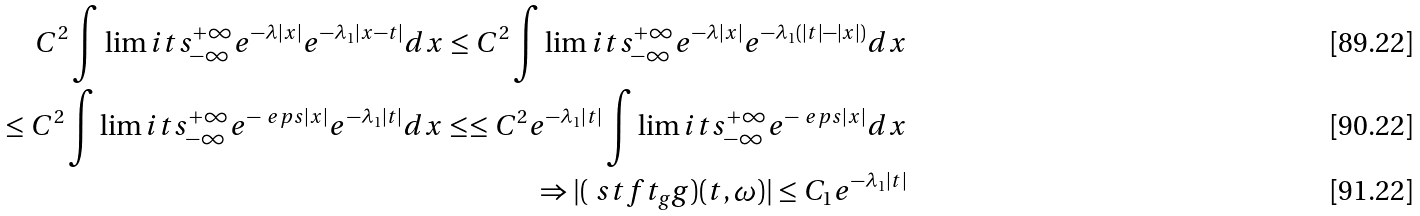<formula> <loc_0><loc_0><loc_500><loc_500>C ^ { 2 } \int \lim i t s _ { - \infty } ^ { + \infty } e ^ { - \lambda | x | } e ^ { - \lambda _ { 1 } | x - t | } d x \leq C ^ { 2 } \int \lim i t s _ { - \infty } ^ { + \infty } e ^ { - \lambda | x | } e ^ { - \lambda _ { 1 } ( | t | - | x | ) } d x \\ \leq C ^ { 2 } \int \lim i t s _ { - \infty } ^ { + \infty } e ^ { - \ e p s | x | } e ^ { - \lambda _ { 1 } | t | } d x \leq \leq C ^ { 2 } e ^ { - \lambda _ { 1 } | t | } \int \lim i t s _ { - \infty } ^ { + \infty } e ^ { - \ e p s | x | } d x \\ \Rightarrow | ( \ s t f t _ { g } g ) ( t , \omega ) | \leq C _ { 1 } e ^ { - \lambda _ { 1 } | t | }</formula> 